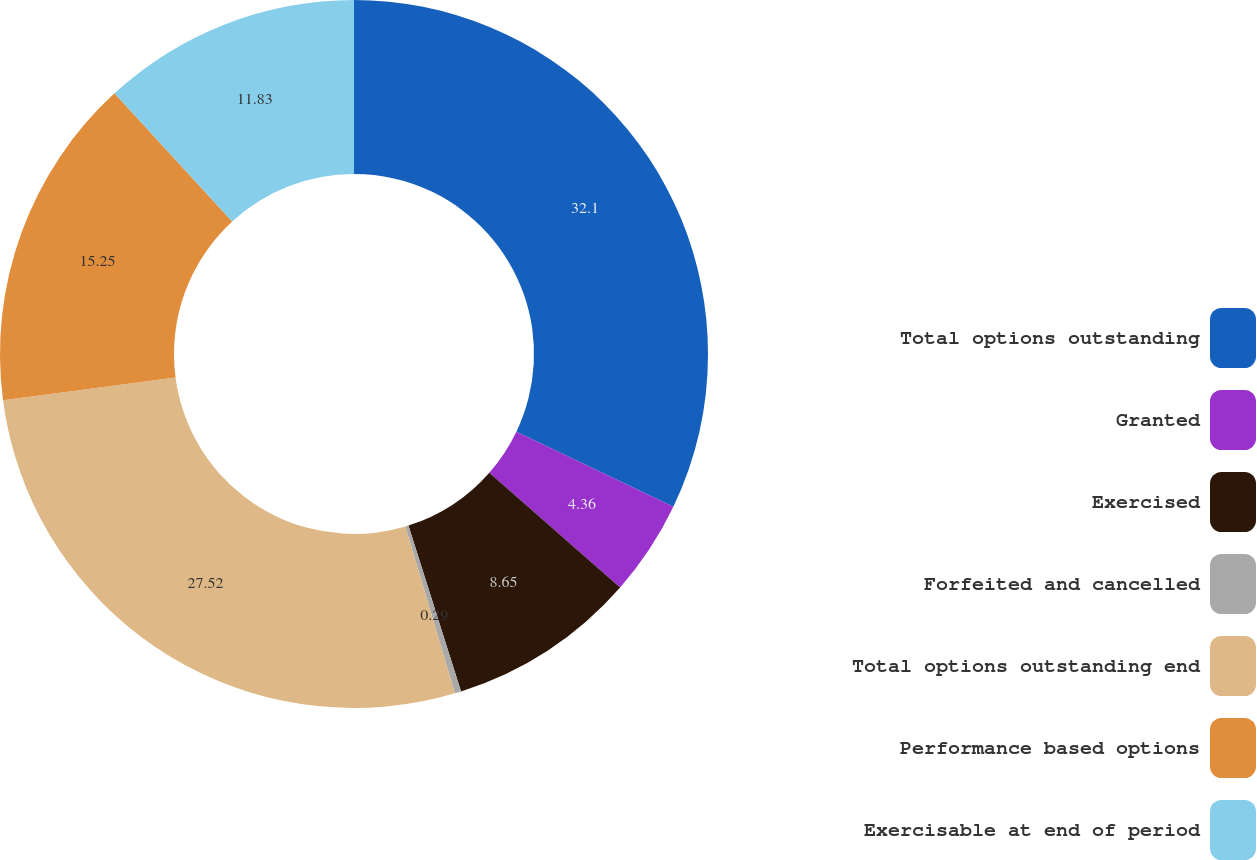<chart> <loc_0><loc_0><loc_500><loc_500><pie_chart><fcel>Total options outstanding<fcel>Granted<fcel>Exercised<fcel>Forfeited and cancelled<fcel>Total options outstanding end<fcel>Performance based options<fcel>Exercisable at end of period<nl><fcel>32.1%<fcel>4.36%<fcel>8.65%<fcel>0.29%<fcel>27.52%<fcel>15.25%<fcel>11.83%<nl></chart> 